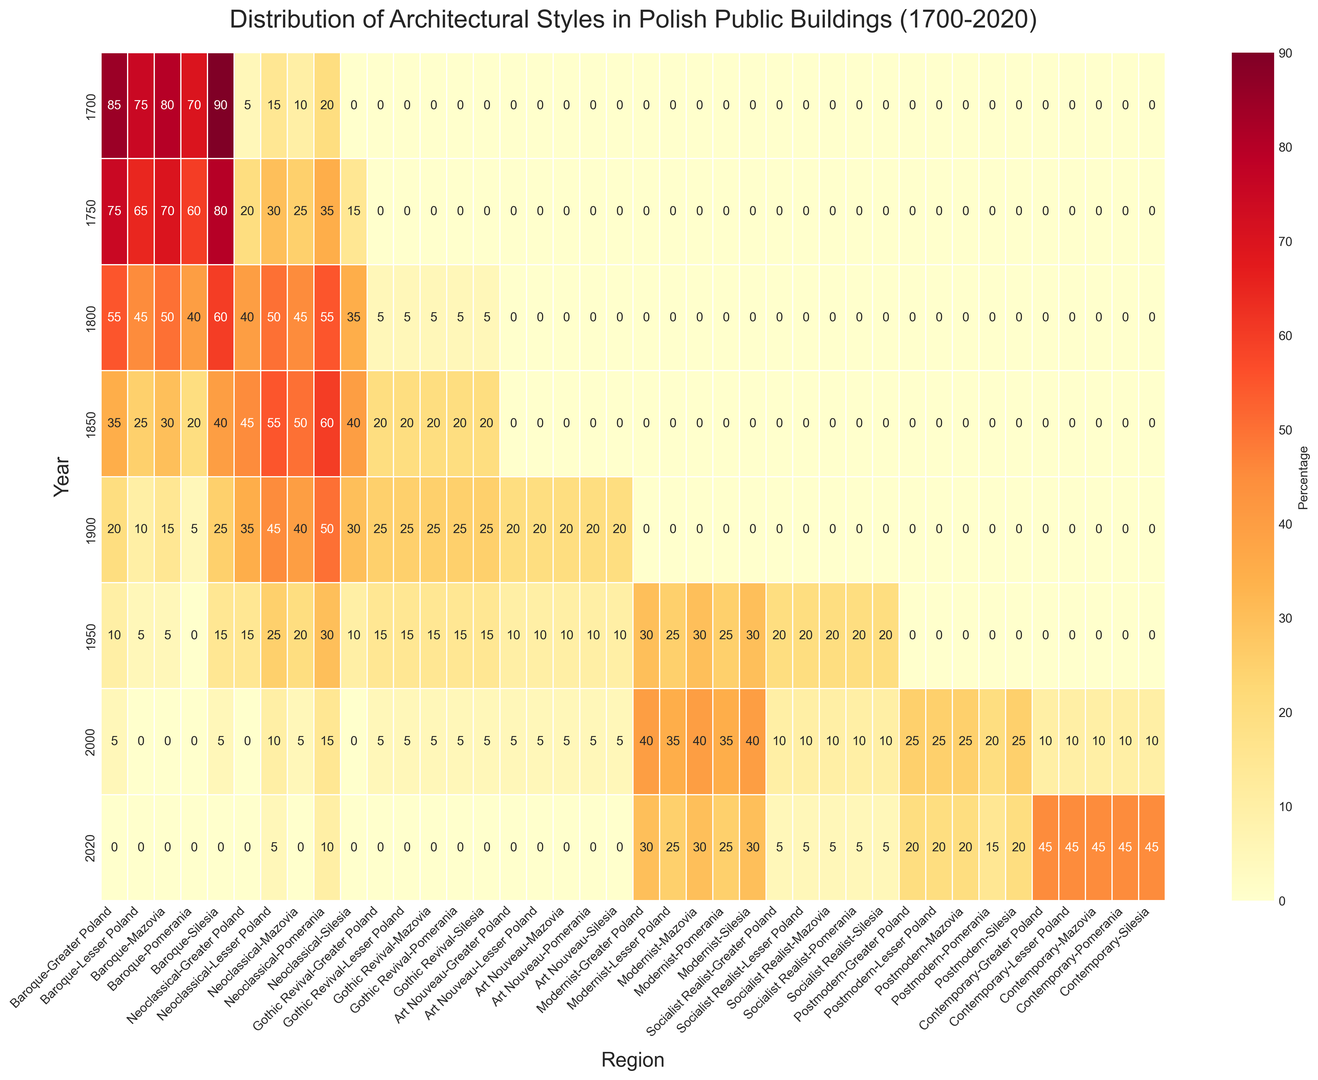Which region had the highest percentage of Baroque architecture in 1700? Looking at the heatmap for the year 1700, the region with the darkest color in the Baroque row indicates the highest percentage. Silesia shows the darkest color for Baroque in 1700.
Answer: Silesia What is the trend in the percentage of Modernist architecture in Lesser Poland from 1900 to 2020? By examining the Modernist row for Lesser Poland over the years 1900, 1950, 2000, and 2020, we see the percentages: 0%, 25%, 35%, and 25%, respectively. This shows an initial rise until 2000 followed by a slight decrease in 2020.
Answer: Rise until 2000, then decrease Compare the percentage of Neoclassical architecture between Mazovia and Greater Poland in 1850. Which region has a higher percentage? From the heatmap, the Neoclassical row in 1850 shows that Mazovia has 50% and Greater Poland has 45%. Therefore, Mazovia has the higher percentage.
Answer: Mazovia Which architectural style dominates in Mazovia in 2020? For Mazovia in 2020, the architectural style with the darkest color in that row represents the highest percentage. Contemporary has the darkest color in Mazovia in 2020.
Answer: Contemporary Calculate the average percentage of Gothic Revival architecture in Pomerania over the available years. The percentages of Gothic Revival in Pomerania in 1800, 1850, 1900, and 1950 are 5%, 20%, 25%, and 15%, respectively. The average is (5 + 20 + 25 + 15) / 4 = 65 / 4 = 16.25%.
Answer: 16.25% Which region shows the most significant shift towards Contemporary architecture between 2000 and 2020? By comparing the Contemporary row between 2000 and 2020 across all regions, we see the increases: Mazovia from 10% to 45%, Lesser Poland from 10% to 45%, Greater Poland from 10% to 45%, Pomerania from 10% to 45%, and Silesia from 10% to 45%. All regions show the same increase of 35%.
Answer: All regions What percentage of Socialist Realist architecture is present in Greater Poland in 1950? In the heatmap for 1950, looking at the Socialist Realist row for Greater Poland, the percentage shown is 20%.
Answer: 20% Identify the year and region with the highest percentage of Baroque architecture. The heatmap shows the darkest color in the Baroque row at Silesia in 1700, indicating the highest percentage.
Answer: 1700, Silesia How did the percentage of Art Nouveau architecture in Silesia change from 1900 to 1950? The heatmap shows the percentage of Art Nouveau in Silesia was 20% in 1900 and 10% in 1950. This indicates a decrease.
Answer: Decreased Which architectural style had no representation in all regions in 1700? In 1700, examining all rows for each region, Gothic Revival, Art Nouveau, Modernist, Socialist Realist, Postmodern, and Contemporary all have 0% values.
Answer: Gothic Revival, Art Nouveau, Modernist, Socialist Realist, Postmodern, Contemporary 